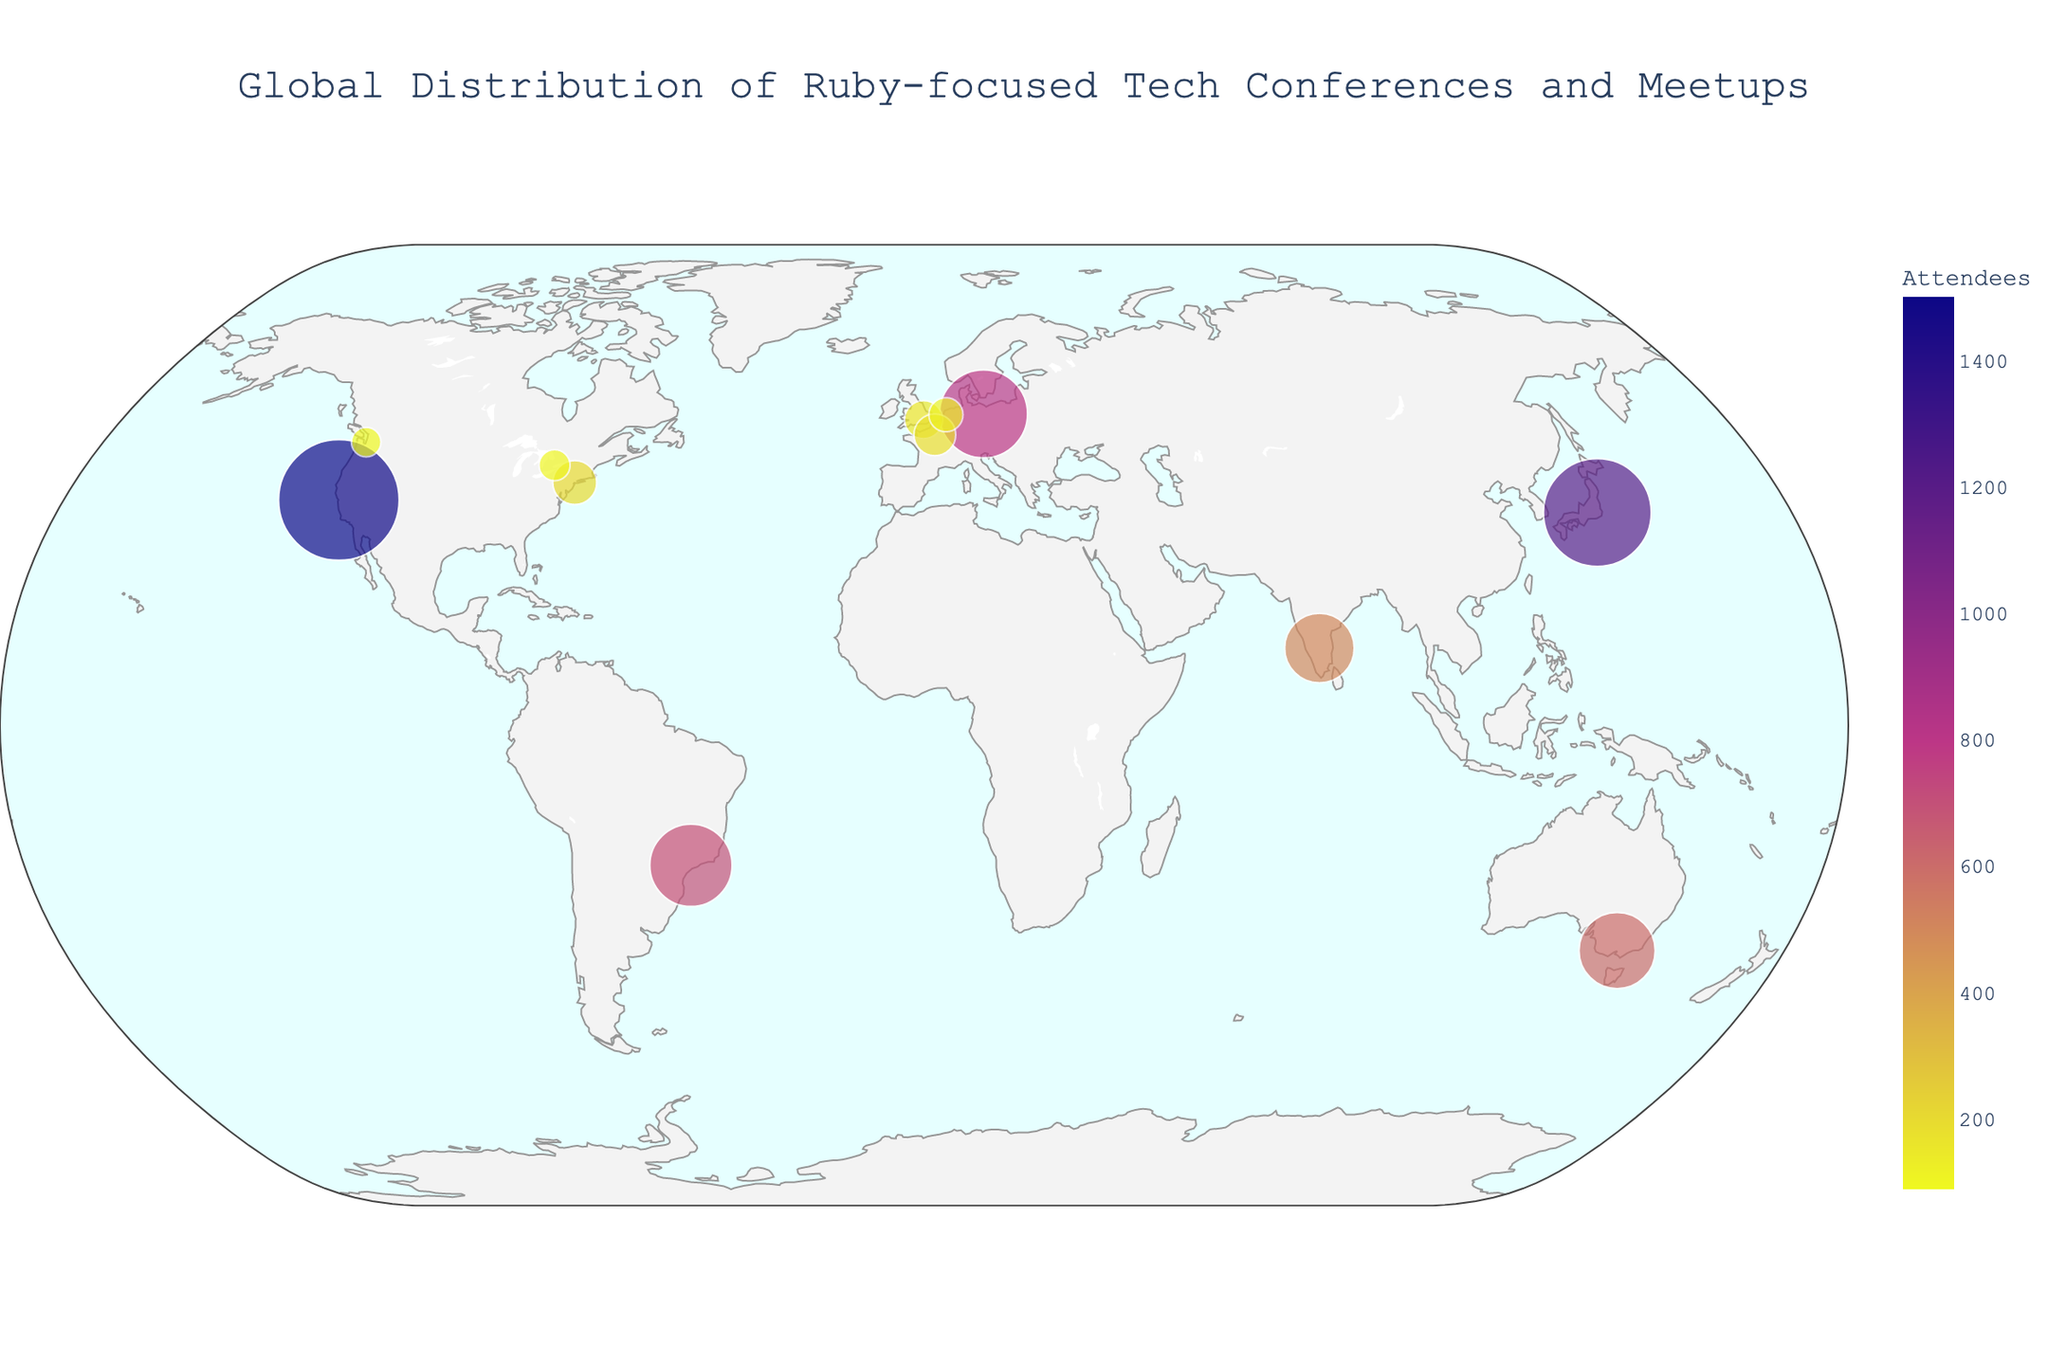What is the title of the figure? The title is displayed at the top center of the figure. It reads "Global Distribution of Ruby-focused Tech Conferences and Meetups".
Answer: Global Distribution of Ruby-focused Tech Conferences and Meetups Which city hosts the event with the highest number of attendees? To find this, look for the largest circle on the map and check the associated hover information. The largest circle is in San Francisco, USA, for RailsConf with 1500 attendees.
Answer: San Francisco How many tech conferences and meetups are plotted in Europe? Identify the circles located within the European continent and count them. Considering Berlin, London, Paris, and Amsterdam, there are four events in Europe.
Answer: 4 What is the color range used in the circles representing the number of attendees? The color scale in the figure ranges from a dark color to a light color as shown in the legend. It uses a sequential Plasma color scale, which varies from dark blue to yellow.
Answer: Dark blue to yellow Which event is held in São Paulo, Brazil, and how many attendees does it have? Locate São Paulo on the map and check the associated hover information. São Paulo, Brazil, hosts RubyConf Brazil with 700 attendees.
Answer: RubyConf Brazil, 700 What is the difference in the number of attendees between RubyKaigi in Tokyo and EuRuKo in Berlin? Check the attendee counts for Tokyo and Berlin from the hover information. RubyKaigi has 1200 attendees, and EuRuKo has 800 attendees. The difference is 1200 - 800 = 400.
Answer: 400 Compare the number of attendees at RubyConf AU in Melbourne and RubyConf India in Bangalore. Which one has more attendees and by how many? Check the attendee counts for Melbourne and Bangalore from the hover information. RubyConf AU has 600 attendees, and RubyConf India has 500 attendees. RubyConf AU has more attendees by 600 - 500 = 100.
Answer: RubyConf AU, 100 How are the locations of the tech conferences and meetups distributed across continents on the map? Observe the circles across different continents. There are events in Asia (Tokyo, Bangalore), North America (San Francisco, New York, Seattle, Toronto), Europe (Berlin, London, Paris, Amsterdam), South America (São Paulo), and Australia (Melbourne).
Answer: Asia, North America, Europe, South America, Australia Which city has a meetup with the smallest number of attendees, and what is the name of the event? Check the smallest circle on the map and its hover information. Seattle, USA, hosts the Seattle.rb Meetup with 90 attendees, making it the smallest.
Answer: Seattle, Seattle.rb Meetup, 90 